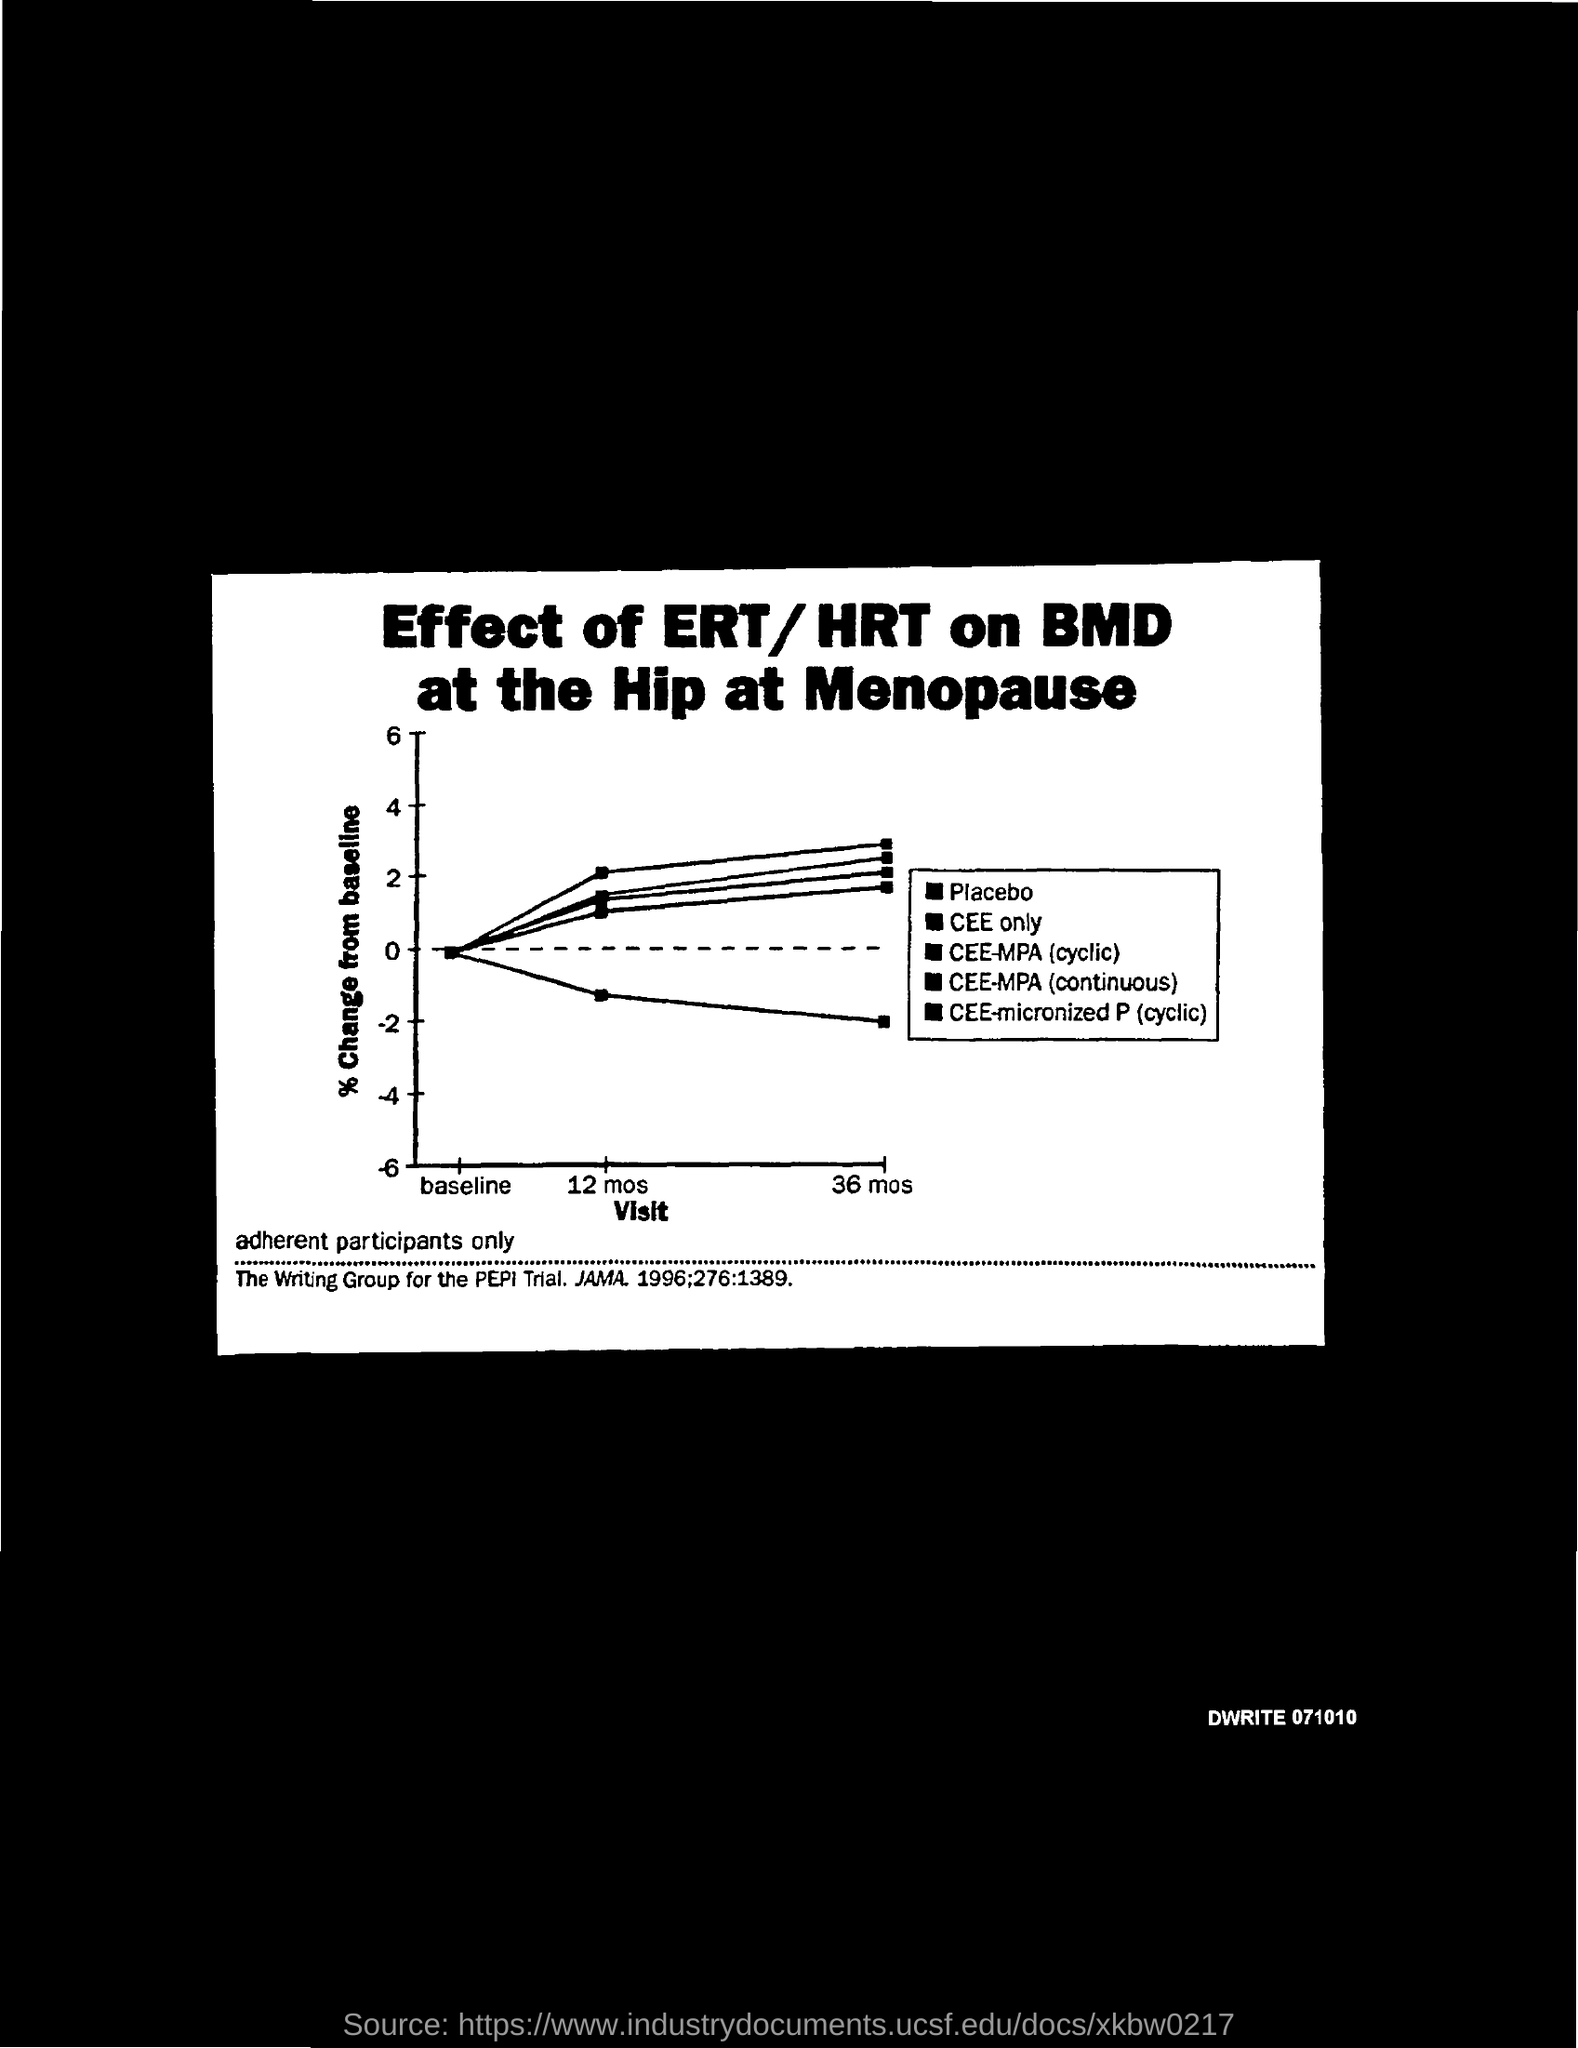Outline some significant characteristics in this image. The document number is DWRITE 071010. 